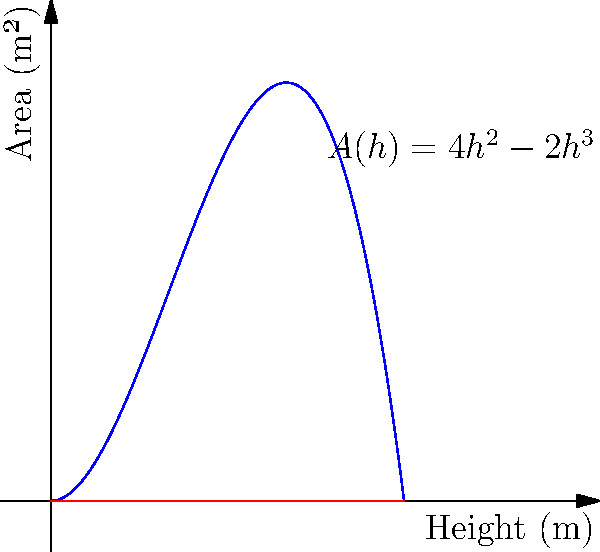A conical fuel tank for a spacecraft has a height of 2 meters. The cross-sectional area $A(h)$ of the fuel at height $h$ meters from the bottom of the tank is given by the polynomial function $A(h) = 4h^2 - 2h^3$. At what height is the cross-sectional area of the fuel largest, and what is this maximum area? To find the maximum area, we need to follow these steps:

1) First, we need to find the derivative of $A(h)$ to determine where the function reaches its maximum:
   $A'(h) = 8h - 6h^2$

2) Set the derivative equal to zero to find the critical points:
   $8h - 6h^2 = 0$
   $2h(4 - 3h) = 0$
   $h = 0$ or $h = \frac{4}{3}$

3) Since $h = 0$ is at the bottom of the tank, the maximum must occur at $h = \frac{4}{3}$ meters.

4) To find the maximum area, we substitute this height back into the original function:
   $A(\frac{4}{3}) = 4(\frac{4}{3})^2 - 2(\frac{4}{3})^3$
                   $= 4(\frac{16}{9}) - 2(\frac{64}{27})$
                   $= \frac{64}{9} - \frac{128}{27}$
                   $= \frac{64}{9} - \frac{128}{27}$
                   $= \frac{64}{9} - \frac{128}{27}$
                   $= \frac{64}{9} - \frac{42.67}{9}$
                   $= \frac{21.33}{9}$
                   $= 2.37$ (rounded to two decimal places)

Therefore, the maximum cross-sectional area is approximately 2.37 square meters and occurs at a height of $\frac{4}{3}$ meters from the bottom of the tank.
Answer: Height: $\frac{4}{3}$ m, Maximum Area: 2.37 m² 